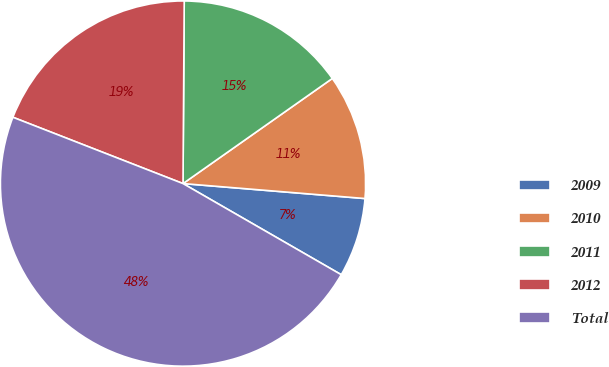<chart> <loc_0><loc_0><loc_500><loc_500><pie_chart><fcel>2009<fcel>2010<fcel>2011<fcel>2012<fcel>Total<nl><fcel>7.01%<fcel>11.07%<fcel>15.13%<fcel>19.19%<fcel>47.6%<nl></chart> 